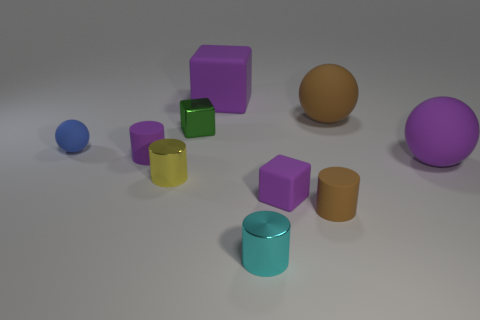The large thing that is the same color as the big block is what shape?
Your answer should be compact. Sphere. There is a matte block behind the small green metal cube; is its color the same as the big matte sphere that is in front of the tiny ball?
Provide a succinct answer. Yes. Do the big rubber block and the cube that is in front of the green metallic block have the same color?
Give a very brief answer. Yes. What number of gray things are either big blocks or cylinders?
Provide a short and direct response. 0. There is a ball left of the big rubber ball behind the small shiny cube; are there any cubes behind it?
Give a very brief answer. Yes. Are there fewer small yellow cylinders than brown things?
Make the answer very short. Yes. There is a purple object that is in front of the tiny yellow cylinder; does it have the same shape as the green metal object?
Make the answer very short. Yes. Is there a large rubber block?
Ensure brevity in your answer.  Yes. What color is the small cylinder behind the big object in front of the big brown sphere that is on the right side of the yellow metallic cylinder?
Make the answer very short. Purple. Are there the same number of small metallic blocks in front of the yellow thing and blocks that are to the right of the large brown rubber ball?
Provide a short and direct response. Yes. 